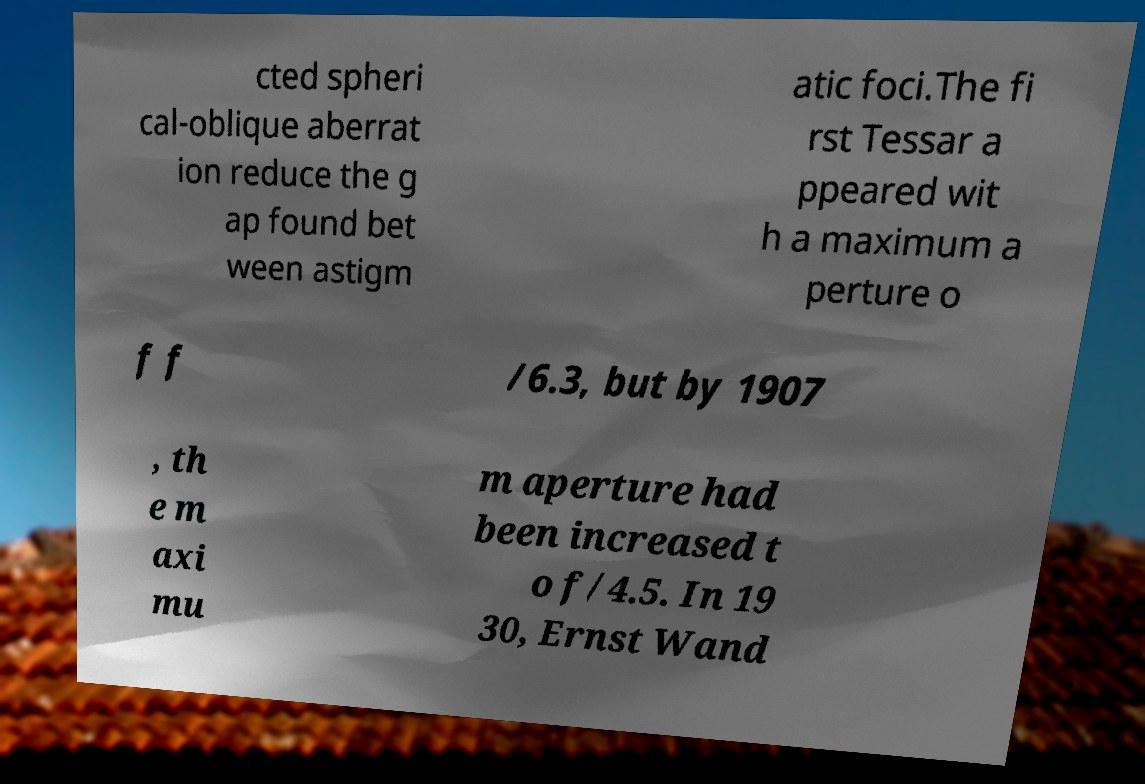Can you read and provide the text displayed in the image?This photo seems to have some interesting text. Can you extract and type it out for me? cted spheri cal-oblique aberrat ion reduce the g ap found bet ween astigm atic foci.The fi rst Tessar a ppeared wit h a maximum a perture o f f /6.3, but by 1907 , th e m axi mu m aperture had been increased t o f/4.5. In 19 30, Ernst Wand 